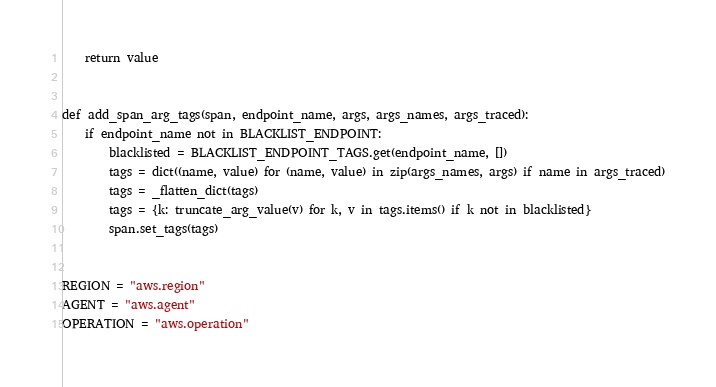<code> <loc_0><loc_0><loc_500><loc_500><_Python_>
    return value


def add_span_arg_tags(span, endpoint_name, args, args_names, args_traced):
    if endpoint_name not in BLACKLIST_ENDPOINT:
        blacklisted = BLACKLIST_ENDPOINT_TAGS.get(endpoint_name, [])
        tags = dict((name, value) for (name, value) in zip(args_names, args) if name in args_traced)
        tags = _flatten_dict(tags)
        tags = {k: truncate_arg_value(v) for k, v in tags.items() if k not in blacklisted}
        span.set_tags(tags)


REGION = "aws.region"
AGENT = "aws.agent"
OPERATION = "aws.operation"
</code> 